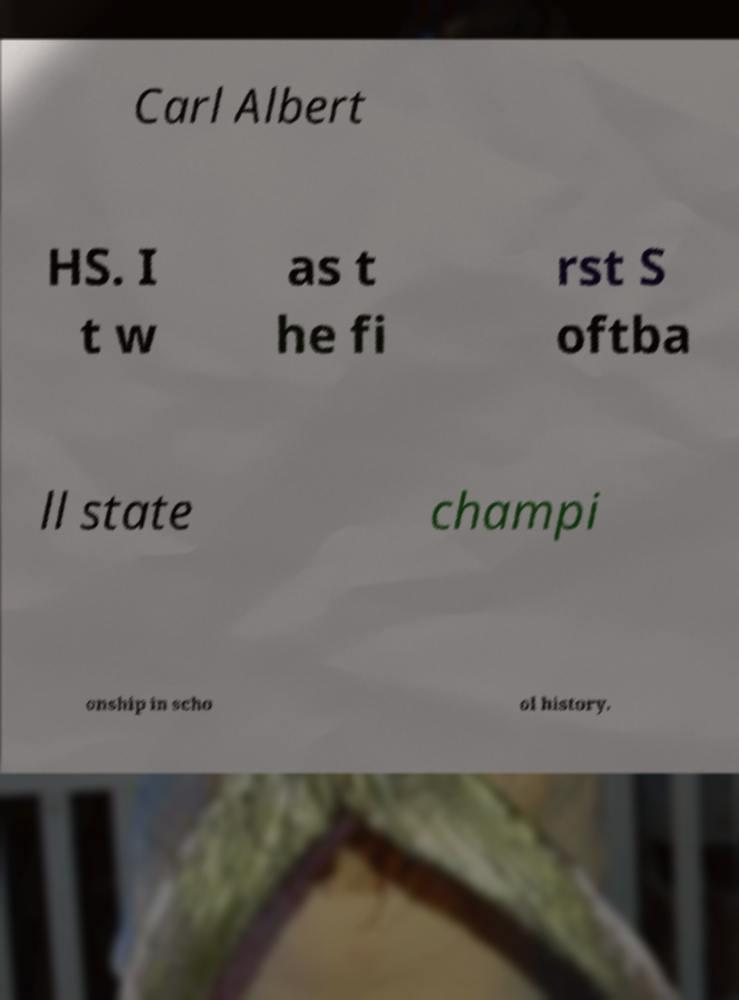There's text embedded in this image that I need extracted. Can you transcribe it verbatim? Carl Albert HS. I t w as t he fi rst S oftba ll state champi onship in scho ol history. 